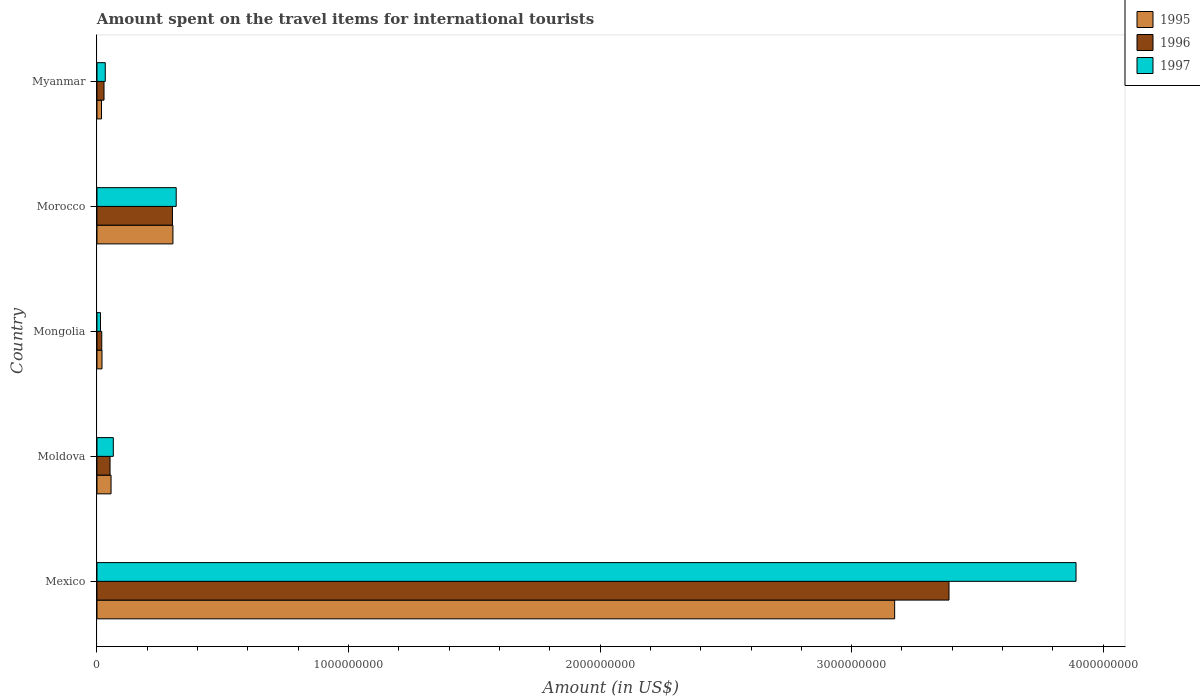How many different coloured bars are there?
Your answer should be compact. 3. Are the number of bars per tick equal to the number of legend labels?
Give a very brief answer. Yes. Are the number of bars on each tick of the Y-axis equal?
Make the answer very short. Yes. How many bars are there on the 2nd tick from the top?
Ensure brevity in your answer.  3. How many bars are there on the 1st tick from the bottom?
Give a very brief answer. 3. What is the label of the 1st group of bars from the top?
Your answer should be very brief. Myanmar. In how many cases, is the number of bars for a given country not equal to the number of legend labels?
Your answer should be compact. 0. What is the amount spent on the travel items for international tourists in 1995 in Moldova?
Provide a succinct answer. 5.60e+07. Across all countries, what is the maximum amount spent on the travel items for international tourists in 1996?
Keep it short and to the point. 3.39e+09. Across all countries, what is the minimum amount spent on the travel items for international tourists in 1995?
Offer a very short reply. 1.80e+07. In which country was the amount spent on the travel items for international tourists in 1997 maximum?
Ensure brevity in your answer.  Mexico. In which country was the amount spent on the travel items for international tourists in 1997 minimum?
Provide a short and direct response. Mongolia. What is the total amount spent on the travel items for international tourists in 1996 in the graph?
Ensure brevity in your answer.  3.79e+09. What is the difference between the amount spent on the travel items for international tourists in 1997 in Mexico and that in Mongolia?
Keep it short and to the point. 3.88e+09. What is the difference between the amount spent on the travel items for international tourists in 1996 in Mongolia and the amount spent on the travel items for international tourists in 1995 in Morocco?
Keep it short and to the point. -2.83e+08. What is the average amount spent on the travel items for international tourists in 1995 per country?
Give a very brief answer. 7.13e+08. What is the difference between the amount spent on the travel items for international tourists in 1995 and amount spent on the travel items for international tourists in 1997 in Myanmar?
Your answer should be compact. -1.50e+07. In how many countries, is the amount spent on the travel items for international tourists in 1997 greater than 1600000000 US$?
Ensure brevity in your answer.  1. What is the ratio of the amount spent on the travel items for international tourists in 1996 in Moldova to that in Morocco?
Give a very brief answer. 0.17. Is the amount spent on the travel items for international tourists in 1997 in Mexico less than that in Moldova?
Your answer should be compact. No. Is the difference between the amount spent on the travel items for international tourists in 1995 in Moldova and Morocco greater than the difference between the amount spent on the travel items for international tourists in 1997 in Moldova and Morocco?
Your response must be concise. Yes. What is the difference between the highest and the second highest amount spent on the travel items for international tourists in 1996?
Your answer should be compact. 3.09e+09. What is the difference between the highest and the lowest amount spent on the travel items for international tourists in 1996?
Offer a terse response. 3.37e+09. In how many countries, is the amount spent on the travel items for international tourists in 1996 greater than the average amount spent on the travel items for international tourists in 1996 taken over all countries?
Your response must be concise. 1. Is the sum of the amount spent on the travel items for international tourists in 1997 in Morocco and Myanmar greater than the maximum amount spent on the travel items for international tourists in 1995 across all countries?
Your response must be concise. No. What does the 3rd bar from the top in Moldova represents?
Keep it short and to the point. 1995. Is it the case that in every country, the sum of the amount spent on the travel items for international tourists in 1997 and amount spent on the travel items for international tourists in 1996 is greater than the amount spent on the travel items for international tourists in 1995?
Offer a very short reply. Yes. How many bars are there?
Your answer should be very brief. 15. Are all the bars in the graph horizontal?
Provide a short and direct response. Yes. How many countries are there in the graph?
Provide a succinct answer. 5. Are the values on the major ticks of X-axis written in scientific E-notation?
Offer a terse response. No. How are the legend labels stacked?
Your response must be concise. Vertical. What is the title of the graph?
Offer a very short reply. Amount spent on the travel items for international tourists. What is the label or title of the X-axis?
Your answer should be compact. Amount (in US$). What is the Amount (in US$) of 1995 in Mexico?
Keep it short and to the point. 3.17e+09. What is the Amount (in US$) of 1996 in Mexico?
Provide a succinct answer. 3.39e+09. What is the Amount (in US$) of 1997 in Mexico?
Ensure brevity in your answer.  3.89e+09. What is the Amount (in US$) in 1995 in Moldova?
Provide a succinct answer. 5.60e+07. What is the Amount (in US$) of 1996 in Moldova?
Ensure brevity in your answer.  5.20e+07. What is the Amount (in US$) in 1997 in Moldova?
Give a very brief answer. 6.50e+07. What is the Amount (in US$) of 1995 in Mongolia?
Give a very brief answer. 2.00e+07. What is the Amount (in US$) of 1996 in Mongolia?
Keep it short and to the point. 1.90e+07. What is the Amount (in US$) in 1997 in Mongolia?
Keep it short and to the point. 1.40e+07. What is the Amount (in US$) in 1995 in Morocco?
Your response must be concise. 3.02e+08. What is the Amount (in US$) in 1996 in Morocco?
Keep it short and to the point. 3.00e+08. What is the Amount (in US$) of 1997 in Morocco?
Your answer should be compact. 3.15e+08. What is the Amount (in US$) in 1995 in Myanmar?
Provide a succinct answer. 1.80e+07. What is the Amount (in US$) in 1996 in Myanmar?
Provide a succinct answer. 2.80e+07. What is the Amount (in US$) of 1997 in Myanmar?
Give a very brief answer. 3.30e+07. Across all countries, what is the maximum Amount (in US$) in 1995?
Your response must be concise. 3.17e+09. Across all countries, what is the maximum Amount (in US$) of 1996?
Provide a succinct answer. 3.39e+09. Across all countries, what is the maximum Amount (in US$) of 1997?
Offer a very short reply. 3.89e+09. Across all countries, what is the minimum Amount (in US$) in 1995?
Your response must be concise. 1.80e+07. Across all countries, what is the minimum Amount (in US$) in 1996?
Provide a short and direct response. 1.90e+07. Across all countries, what is the minimum Amount (in US$) in 1997?
Your response must be concise. 1.40e+07. What is the total Amount (in US$) in 1995 in the graph?
Give a very brief answer. 3.57e+09. What is the total Amount (in US$) in 1996 in the graph?
Give a very brief answer. 3.79e+09. What is the total Amount (in US$) in 1997 in the graph?
Your answer should be compact. 4.32e+09. What is the difference between the Amount (in US$) of 1995 in Mexico and that in Moldova?
Give a very brief answer. 3.12e+09. What is the difference between the Amount (in US$) of 1996 in Mexico and that in Moldova?
Your response must be concise. 3.34e+09. What is the difference between the Amount (in US$) of 1997 in Mexico and that in Moldova?
Offer a very short reply. 3.83e+09. What is the difference between the Amount (in US$) of 1995 in Mexico and that in Mongolia?
Your answer should be very brief. 3.15e+09. What is the difference between the Amount (in US$) of 1996 in Mexico and that in Mongolia?
Give a very brief answer. 3.37e+09. What is the difference between the Amount (in US$) in 1997 in Mexico and that in Mongolia?
Ensure brevity in your answer.  3.88e+09. What is the difference between the Amount (in US$) of 1995 in Mexico and that in Morocco?
Offer a very short reply. 2.87e+09. What is the difference between the Amount (in US$) of 1996 in Mexico and that in Morocco?
Provide a short and direct response. 3.09e+09. What is the difference between the Amount (in US$) in 1997 in Mexico and that in Morocco?
Provide a succinct answer. 3.58e+09. What is the difference between the Amount (in US$) of 1995 in Mexico and that in Myanmar?
Your answer should be very brief. 3.15e+09. What is the difference between the Amount (in US$) of 1996 in Mexico and that in Myanmar?
Ensure brevity in your answer.  3.36e+09. What is the difference between the Amount (in US$) in 1997 in Mexico and that in Myanmar?
Make the answer very short. 3.86e+09. What is the difference between the Amount (in US$) of 1995 in Moldova and that in Mongolia?
Your answer should be compact. 3.60e+07. What is the difference between the Amount (in US$) of 1996 in Moldova and that in Mongolia?
Offer a very short reply. 3.30e+07. What is the difference between the Amount (in US$) of 1997 in Moldova and that in Mongolia?
Provide a succinct answer. 5.10e+07. What is the difference between the Amount (in US$) of 1995 in Moldova and that in Morocco?
Your answer should be very brief. -2.46e+08. What is the difference between the Amount (in US$) in 1996 in Moldova and that in Morocco?
Ensure brevity in your answer.  -2.48e+08. What is the difference between the Amount (in US$) of 1997 in Moldova and that in Morocco?
Offer a terse response. -2.50e+08. What is the difference between the Amount (in US$) in 1995 in Moldova and that in Myanmar?
Give a very brief answer. 3.80e+07. What is the difference between the Amount (in US$) of 1996 in Moldova and that in Myanmar?
Make the answer very short. 2.40e+07. What is the difference between the Amount (in US$) of 1997 in Moldova and that in Myanmar?
Your answer should be compact. 3.20e+07. What is the difference between the Amount (in US$) of 1995 in Mongolia and that in Morocco?
Give a very brief answer. -2.82e+08. What is the difference between the Amount (in US$) of 1996 in Mongolia and that in Morocco?
Provide a short and direct response. -2.81e+08. What is the difference between the Amount (in US$) in 1997 in Mongolia and that in Morocco?
Give a very brief answer. -3.01e+08. What is the difference between the Amount (in US$) of 1995 in Mongolia and that in Myanmar?
Your response must be concise. 2.00e+06. What is the difference between the Amount (in US$) in 1996 in Mongolia and that in Myanmar?
Your answer should be compact. -9.00e+06. What is the difference between the Amount (in US$) of 1997 in Mongolia and that in Myanmar?
Ensure brevity in your answer.  -1.90e+07. What is the difference between the Amount (in US$) in 1995 in Morocco and that in Myanmar?
Give a very brief answer. 2.84e+08. What is the difference between the Amount (in US$) of 1996 in Morocco and that in Myanmar?
Offer a terse response. 2.72e+08. What is the difference between the Amount (in US$) in 1997 in Morocco and that in Myanmar?
Provide a succinct answer. 2.82e+08. What is the difference between the Amount (in US$) in 1995 in Mexico and the Amount (in US$) in 1996 in Moldova?
Your answer should be very brief. 3.12e+09. What is the difference between the Amount (in US$) in 1995 in Mexico and the Amount (in US$) in 1997 in Moldova?
Keep it short and to the point. 3.11e+09. What is the difference between the Amount (in US$) of 1996 in Mexico and the Amount (in US$) of 1997 in Moldova?
Ensure brevity in your answer.  3.32e+09. What is the difference between the Amount (in US$) of 1995 in Mexico and the Amount (in US$) of 1996 in Mongolia?
Make the answer very short. 3.15e+09. What is the difference between the Amount (in US$) of 1995 in Mexico and the Amount (in US$) of 1997 in Mongolia?
Provide a succinct answer. 3.16e+09. What is the difference between the Amount (in US$) of 1996 in Mexico and the Amount (in US$) of 1997 in Mongolia?
Your answer should be compact. 3.37e+09. What is the difference between the Amount (in US$) in 1995 in Mexico and the Amount (in US$) in 1996 in Morocco?
Offer a very short reply. 2.87e+09. What is the difference between the Amount (in US$) of 1995 in Mexico and the Amount (in US$) of 1997 in Morocco?
Keep it short and to the point. 2.86e+09. What is the difference between the Amount (in US$) in 1996 in Mexico and the Amount (in US$) in 1997 in Morocco?
Provide a succinct answer. 3.07e+09. What is the difference between the Amount (in US$) of 1995 in Mexico and the Amount (in US$) of 1996 in Myanmar?
Provide a short and direct response. 3.14e+09. What is the difference between the Amount (in US$) of 1995 in Mexico and the Amount (in US$) of 1997 in Myanmar?
Your response must be concise. 3.14e+09. What is the difference between the Amount (in US$) of 1996 in Mexico and the Amount (in US$) of 1997 in Myanmar?
Your answer should be compact. 3.35e+09. What is the difference between the Amount (in US$) of 1995 in Moldova and the Amount (in US$) of 1996 in Mongolia?
Provide a succinct answer. 3.70e+07. What is the difference between the Amount (in US$) in 1995 in Moldova and the Amount (in US$) in 1997 in Mongolia?
Provide a succinct answer. 4.20e+07. What is the difference between the Amount (in US$) in 1996 in Moldova and the Amount (in US$) in 1997 in Mongolia?
Provide a short and direct response. 3.80e+07. What is the difference between the Amount (in US$) of 1995 in Moldova and the Amount (in US$) of 1996 in Morocco?
Offer a very short reply. -2.44e+08. What is the difference between the Amount (in US$) in 1995 in Moldova and the Amount (in US$) in 1997 in Morocco?
Offer a terse response. -2.59e+08. What is the difference between the Amount (in US$) of 1996 in Moldova and the Amount (in US$) of 1997 in Morocco?
Keep it short and to the point. -2.63e+08. What is the difference between the Amount (in US$) of 1995 in Moldova and the Amount (in US$) of 1996 in Myanmar?
Keep it short and to the point. 2.80e+07. What is the difference between the Amount (in US$) of 1995 in Moldova and the Amount (in US$) of 1997 in Myanmar?
Keep it short and to the point. 2.30e+07. What is the difference between the Amount (in US$) in 1996 in Moldova and the Amount (in US$) in 1997 in Myanmar?
Keep it short and to the point. 1.90e+07. What is the difference between the Amount (in US$) in 1995 in Mongolia and the Amount (in US$) in 1996 in Morocco?
Offer a very short reply. -2.80e+08. What is the difference between the Amount (in US$) in 1995 in Mongolia and the Amount (in US$) in 1997 in Morocco?
Make the answer very short. -2.95e+08. What is the difference between the Amount (in US$) in 1996 in Mongolia and the Amount (in US$) in 1997 in Morocco?
Keep it short and to the point. -2.96e+08. What is the difference between the Amount (in US$) in 1995 in Mongolia and the Amount (in US$) in 1996 in Myanmar?
Offer a very short reply. -8.00e+06. What is the difference between the Amount (in US$) in 1995 in Mongolia and the Amount (in US$) in 1997 in Myanmar?
Offer a terse response. -1.30e+07. What is the difference between the Amount (in US$) in 1996 in Mongolia and the Amount (in US$) in 1997 in Myanmar?
Give a very brief answer. -1.40e+07. What is the difference between the Amount (in US$) in 1995 in Morocco and the Amount (in US$) in 1996 in Myanmar?
Ensure brevity in your answer.  2.74e+08. What is the difference between the Amount (in US$) of 1995 in Morocco and the Amount (in US$) of 1997 in Myanmar?
Provide a succinct answer. 2.69e+08. What is the difference between the Amount (in US$) of 1996 in Morocco and the Amount (in US$) of 1997 in Myanmar?
Offer a very short reply. 2.67e+08. What is the average Amount (in US$) of 1995 per country?
Your answer should be very brief. 7.13e+08. What is the average Amount (in US$) in 1996 per country?
Make the answer very short. 7.57e+08. What is the average Amount (in US$) in 1997 per country?
Make the answer very short. 8.64e+08. What is the difference between the Amount (in US$) of 1995 and Amount (in US$) of 1996 in Mexico?
Keep it short and to the point. -2.16e+08. What is the difference between the Amount (in US$) of 1995 and Amount (in US$) of 1997 in Mexico?
Make the answer very short. -7.21e+08. What is the difference between the Amount (in US$) of 1996 and Amount (in US$) of 1997 in Mexico?
Make the answer very short. -5.05e+08. What is the difference between the Amount (in US$) in 1995 and Amount (in US$) in 1996 in Moldova?
Provide a succinct answer. 4.00e+06. What is the difference between the Amount (in US$) in 1995 and Amount (in US$) in 1997 in Moldova?
Offer a terse response. -9.00e+06. What is the difference between the Amount (in US$) of 1996 and Amount (in US$) of 1997 in Moldova?
Ensure brevity in your answer.  -1.30e+07. What is the difference between the Amount (in US$) in 1996 and Amount (in US$) in 1997 in Mongolia?
Ensure brevity in your answer.  5.00e+06. What is the difference between the Amount (in US$) in 1995 and Amount (in US$) in 1997 in Morocco?
Offer a very short reply. -1.30e+07. What is the difference between the Amount (in US$) of 1996 and Amount (in US$) of 1997 in Morocco?
Offer a terse response. -1.50e+07. What is the difference between the Amount (in US$) in 1995 and Amount (in US$) in 1996 in Myanmar?
Offer a terse response. -1.00e+07. What is the difference between the Amount (in US$) in 1995 and Amount (in US$) in 1997 in Myanmar?
Keep it short and to the point. -1.50e+07. What is the difference between the Amount (in US$) in 1996 and Amount (in US$) in 1997 in Myanmar?
Give a very brief answer. -5.00e+06. What is the ratio of the Amount (in US$) of 1995 in Mexico to that in Moldova?
Provide a succinct answer. 56.62. What is the ratio of the Amount (in US$) of 1996 in Mexico to that in Moldova?
Offer a terse response. 65.13. What is the ratio of the Amount (in US$) in 1997 in Mexico to that in Moldova?
Your answer should be very brief. 59.88. What is the ratio of the Amount (in US$) of 1995 in Mexico to that in Mongolia?
Make the answer very short. 158.55. What is the ratio of the Amount (in US$) in 1996 in Mexico to that in Mongolia?
Provide a short and direct response. 178.26. What is the ratio of the Amount (in US$) in 1997 in Mexico to that in Mongolia?
Provide a succinct answer. 278. What is the ratio of the Amount (in US$) of 1996 in Mexico to that in Morocco?
Offer a terse response. 11.29. What is the ratio of the Amount (in US$) of 1997 in Mexico to that in Morocco?
Make the answer very short. 12.36. What is the ratio of the Amount (in US$) of 1995 in Mexico to that in Myanmar?
Ensure brevity in your answer.  176.17. What is the ratio of the Amount (in US$) of 1996 in Mexico to that in Myanmar?
Make the answer very short. 120.96. What is the ratio of the Amount (in US$) of 1997 in Mexico to that in Myanmar?
Your response must be concise. 117.94. What is the ratio of the Amount (in US$) of 1996 in Moldova to that in Mongolia?
Provide a short and direct response. 2.74. What is the ratio of the Amount (in US$) of 1997 in Moldova to that in Mongolia?
Your answer should be compact. 4.64. What is the ratio of the Amount (in US$) of 1995 in Moldova to that in Morocco?
Your answer should be very brief. 0.19. What is the ratio of the Amount (in US$) of 1996 in Moldova to that in Morocco?
Offer a very short reply. 0.17. What is the ratio of the Amount (in US$) of 1997 in Moldova to that in Morocco?
Provide a short and direct response. 0.21. What is the ratio of the Amount (in US$) of 1995 in Moldova to that in Myanmar?
Offer a terse response. 3.11. What is the ratio of the Amount (in US$) of 1996 in Moldova to that in Myanmar?
Offer a terse response. 1.86. What is the ratio of the Amount (in US$) in 1997 in Moldova to that in Myanmar?
Your answer should be compact. 1.97. What is the ratio of the Amount (in US$) of 1995 in Mongolia to that in Morocco?
Offer a terse response. 0.07. What is the ratio of the Amount (in US$) in 1996 in Mongolia to that in Morocco?
Keep it short and to the point. 0.06. What is the ratio of the Amount (in US$) of 1997 in Mongolia to that in Morocco?
Your answer should be very brief. 0.04. What is the ratio of the Amount (in US$) in 1996 in Mongolia to that in Myanmar?
Your answer should be compact. 0.68. What is the ratio of the Amount (in US$) of 1997 in Mongolia to that in Myanmar?
Make the answer very short. 0.42. What is the ratio of the Amount (in US$) of 1995 in Morocco to that in Myanmar?
Provide a succinct answer. 16.78. What is the ratio of the Amount (in US$) of 1996 in Morocco to that in Myanmar?
Provide a succinct answer. 10.71. What is the ratio of the Amount (in US$) of 1997 in Morocco to that in Myanmar?
Keep it short and to the point. 9.55. What is the difference between the highest and the second highest Amount (in US$) in 1995?
Ensure brevity in your answer.  2.87e+09. What is the difference between the highest and the second highest Amount (in US$) of 1996?
Offer a very short reply. 3.09e+09. What is the difference between the highest and the second highest Amount (in US$) of 1997?
Offer a very short reply. 3.58e+09. What is the difference between the highest and the lowest Amount (in US$) in 1995?
Give a very brief answer. 3.15e+09. What is the difference between the highest and the lowest Amount (in US$) of 1996?
Your answer should be very brief. 3.37e+09. What is the difference between the highest and the lowest Amount (in US$) in 1997?
Your answer should be compact. 3.88e+09. 